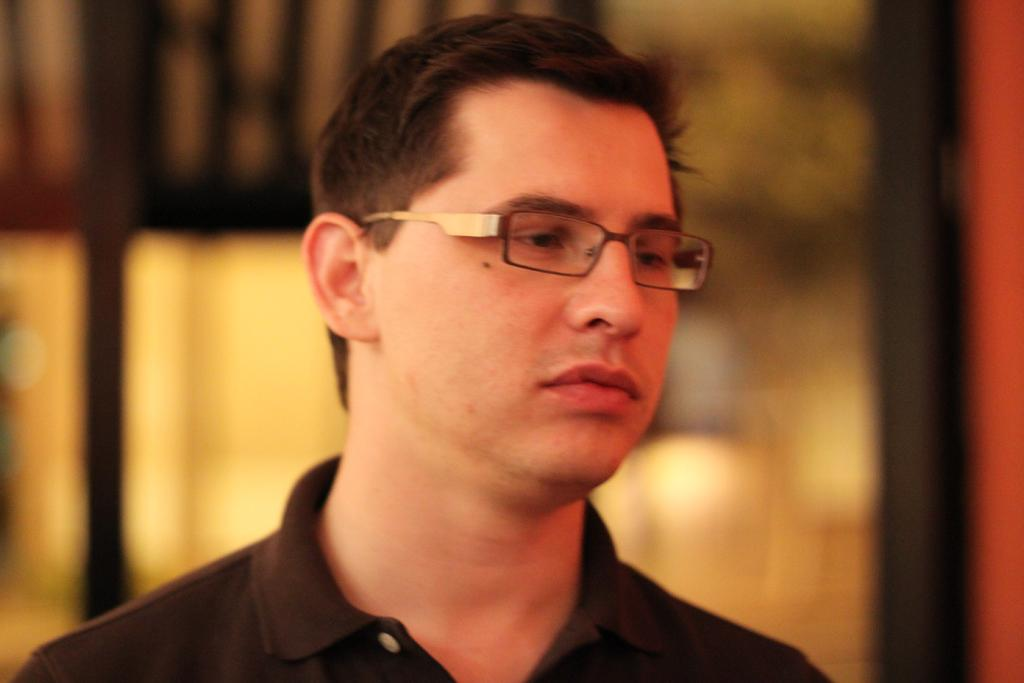Who is the main subject in the image? There is a man in the image. What is the man wearing on his upper body? The man is wearing a black T-shirt. What accessory is the man wearing on his face? The man is wearing spectacles. Can you describe the background of the image? The background of the image appears blurry. Where is the clam located in the image? There is no clam present in the image. What type of faucet can be seen in the image? There is no faucet present in the image. 